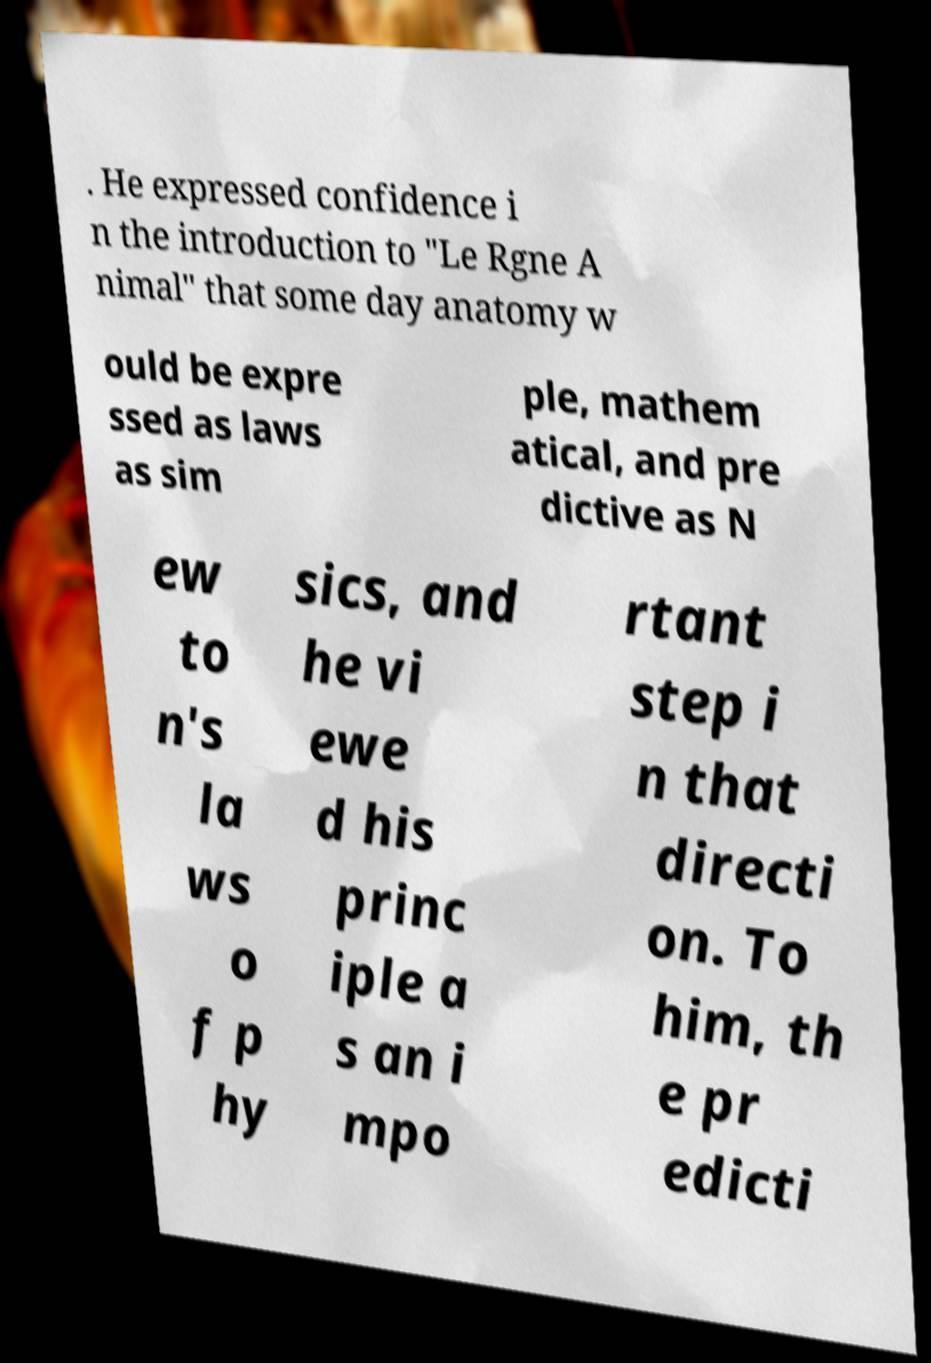There's text embedded in this image that I need extracted. Can you transcribe it verbatim? . He expressed confidence i n the introduction to "Le Rgne A nimal" that some day anatomy w ould be expre ssed as laws as sim ple, mathem atical, and pre dictive as N ew to n's la ws o f p hy sics, and he vi ewe d his princ iple a s an i mpo rtant step i n that directi on. To him, th e pr edicti 